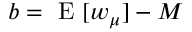<formula> <loc_0><loc_0><loc_500><loc_500>b = E [ w _ { \mu } ] - M</formula> 